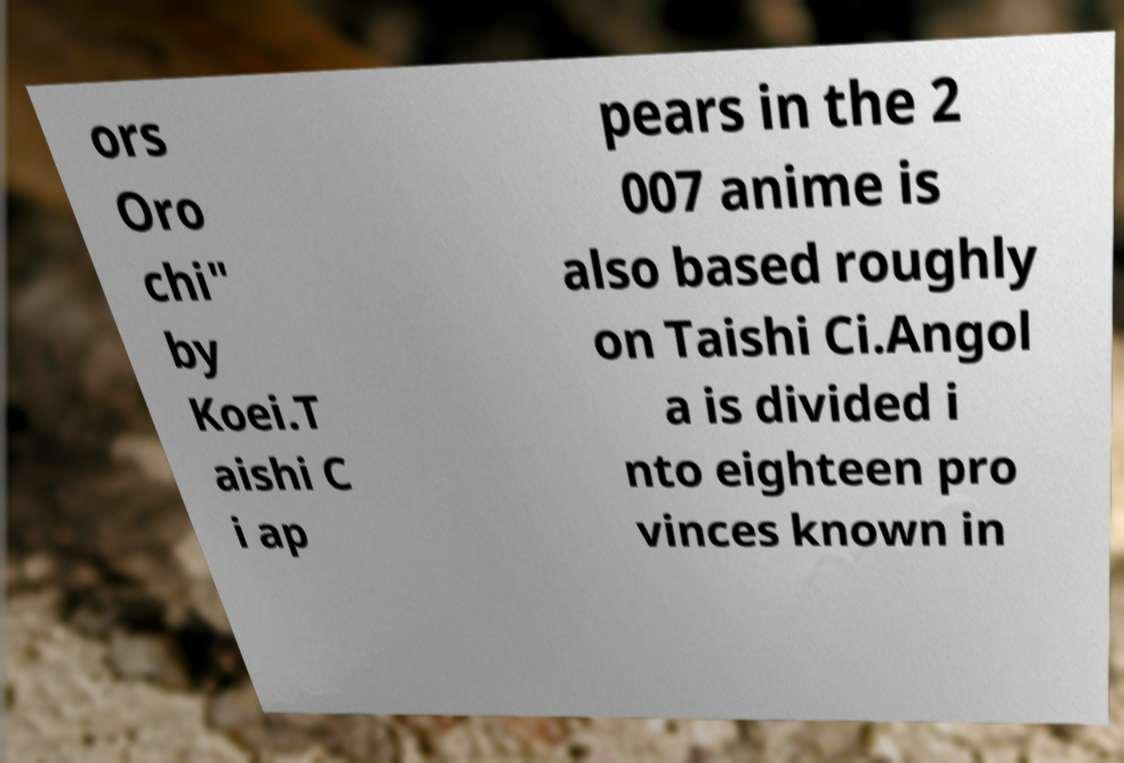I need the written content from this picture converted into text. Can you do that? ors Oro chi" by Koei.T aishi C i ap pears in the 2 007 anime is also based roughly on Taishi Ci.Angol a is divided i nto eighteen pro vinces known in 